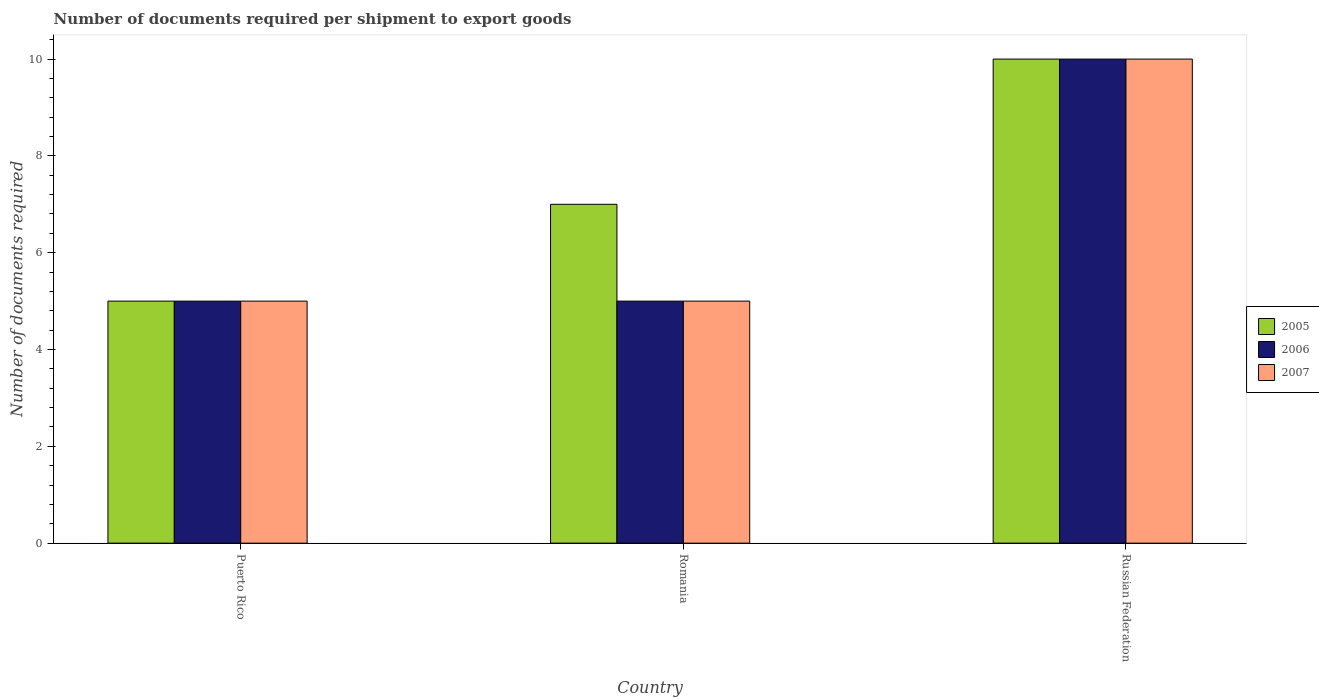How many different coloured bars are there?
Provide a short and direct response. 3. How many groups of bars are there?
Provide a short and direct response. 3. Are the number of bars on each tick of the X-axis equal?
Make the answer very short. Yes. How many bars are there on the 1st tick from the right?
Offer a very short reply. 3. What is the label of the 2nd group of bars from the left?
Provide a succinct answer. Romania. In how many cases, is the number of bars for a given country not equal to the number of legend labels?
Your answer should be very brief. 0. In which country was the number of documents required per shipment to export goods in 2006 maximum?
Your response must be concise. Russian Federation. In which country was the number of documents required per shipment to export goods in 2007 minimum?
Your answer should be very brief. Puerto Rico. What is the total number of documents required per shipment to export goods in 2005 in the graph?
Your response must be concise. 22. What is the difference between the number of documents required per shipment to export goods in 2005 in Romania and that in Russian Federation?
Provide a short and direct response. -3. What is the difference between the number of documents required per shipment to export goods in 2005 in Puerto Rico and the number of documents required per shipment to export goods in 2006 in Romania?
Your answer should be very brief. 0. What is the average number of documents required per shipment to export goods in 2006 per country?
Provide a succinct answer. 6.67. What is the difference between the number of documents required per shipment to export goods of/in 2005 and number of documents required per shipment to export goods of/in 2006 in Puerto Rico?
Give a very brief answer. 0. Is the number of documents required per shipment to export goods in 2007 in Romania less than that in Russian Federation?
Provide a short and direct response. Yes. What is the difference between the highest and the second highest number of documents required per shipment to export goods in 2006?
Offer a terse response. 5. Is the sum of the number of documents required per shipment to export goods in 2007 in Romania and Russian Federation greater than the maximum number of documents required per shipment to export goods in 2006 across all countries?
Make the answer very short. Yes. Is it the case that in every country, the sum of the number of documents required per shipment to export goods in 2005 and number of documents required per shipment to export goods in 2006 is greater than the number of documents required per shipment to export goods in 2007?
Provide a short and direct response. Yes. How many bars are there?
Your answer should be compact. 9. Are all the bars in the graph horizontal?
Provide a short and direct response. No. How many countries are there in the graph?
Your answer should be compact. 3. Are the values on the major ticks of Y-axis written in scientific E-notation?
Ensure brevity in your answer.  No. Does the graph contain grids?
Give a very brief answer. No. Where does the legend appear in the graph?
Offer a very short reply. Center right. How many legend labels are there?
Make the answer very short. 3. What is the title of the graph?
Ensure brevity in your answer.  Number of documents required per shipment to export goods. Does "1968" appear as one of the legend labels in the graph?
Keep it short and to the point. No. What is the label or title of the Y-axis?
Provide a short and direct response. Number of documents required. What is the Number of documents required of 2007 in Puerto Rico?
Make the answer very short. 5. What is the Number of documents required in 2007 in Romania?
Provide a succinct answer. 5. What is the Number of documents required in 2006 in Russian Federation?
Offer a terse response. 10. What is the Number of documents required of 2007 in Russian Federation?
Give a very brief answer. 10. Across all countries, what is the maximum Number of documents required in 2005?
Offer a terse response. 10. Across all countries, what is the maximum Number of documents required in 2006?
Provide a short and direct response. 10. Across all countries, what is the minimum Number of documents required of 2006?
Your answer should be compact. 5. What is the total Number of documents required of 2007 in the graph?
Provide a short and direct response. 20. What is the difference between the Number of documents required in 2005 in Puerto Rico and that in Russian Federation?
Your answer should be compact. -5. What is the difference between the Number of documents required in 2006 in Puerto Rico and that in Russian Federation?
Your response must be concise. -5. What is the difference between the Number of documents required of 2007 in Puerto Rico and that in Russian Federation?
Your response must be concise. -5. What is the difference between the Number of documents required in 2005 in Romania and that in Russian Federation?
Your answer should be compact. -3. What is the difference between the Number of documents required in 2007 in Romania and that in Russian Federation?
Your answer should be compact. -5. What is the difference between the Number of documents required in 2005 in Puerto Rico and the Number of documents required in 2007 in Romania?
Ensure brevity in your answer.  0. What is the difference between the Number of documents required of 2006 in Puerto Rico and the Number of documents required of 2007 in Romania?
Offer a terse response. 0. What is the difference between the Number of documents required in 2005 in Puerto Rico and the Number of documents required in 2006 in Russian Federation?
Give a very brief answer. -5. What is the difference between the Number of documents required in 2005 in Puerto Rico and the Number of documents required in 2007 in Russian Federation?
Your answer should be compact. -5. What is the difference between the Number of documents required of 2005 in Romania and the Number of documents required of 2007 in Russian Federation?
Provide a succinct answer. -3. What is the average Number of documents required in 2005 per country?
Offer a terse response. 7.33. What is the average Number of documents required in 2006 per country?
Make the answer very short. 6.67. What is the difference between the Number of documents required in 2005 and Number of documents required in 2006 in Romania?
Make the answer very short. 2. What is the difference between the Number of documents required of 2005 and Number of documents required of 2007 in Romania?
Offer a very short reply. 2. What is the difference between the Number of documents required of 2006 and Number of documents required of 2007 in Romania?
Keep it short and to the point. 0. What is the difference between the Number of documents required in 2005 and Number of documents required in 2006 in Russian Federation?
Keep it short and to the point. 0. What is the difference between the Number of documents required in 2005 and Number of documents required in 2007 in Russian Federation?
Provide a succinct answer. 0. What is the ratio of the Number of documents required of 2006 in Puerto Rico to that in Romania?
Offer a terse response. 1. What is the ratio of the Number of documents required in 2007 in Puerto Rico to that in Romania?
Keep it short and to the point. 1. What is the ratio of the Number of documents required in 2006 in Puerto Rico to that in Russian Federation?
Make the answer very short. 0.5. What is the ratio of the Number of documents required in 2007 in Puerto Rico to that in Russian Federation?
Your answer should be very brief. 0.5. What is the ratio of the Number of documents required of 2005 in Romania to that in Russian Federation?
Ensure brevity in your answer.  0.7. What is the ratio of the Number of documents required of 2006 in Romania to that in Russian Federation?
Make the answer very short. 0.5. What is the difference between the highest and the second highest Number of documents required of 2006?
Offer a very short reply. 5. What is the difference between the highest and the second highest Number of documents required of 2007?
Offer a very short reply. 5. What is the difference between the highest and the lowest Number of documents required of 2006?
Offer a terse response. 5. 